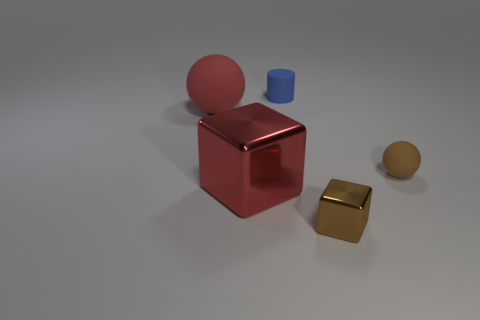There is a metal object that is the same color as the tiny matte ball; what shape is it?
Keep it short and to the point. Cube. How many rubber cylinders have the same size as the blue rubber object?
Your response must be concise. 0. What material is the big red object that is the same shape as the brown metallic thing?
Your answer should be very brief. Metal. What color is the rubber sphere that is left of the brown ball?
Your answer should be very brief. Red. Are there more small brown rubber balls to the left of the large metal cube than brown blocks?
Give a very brief answer. No. What is the color of the small sphere?
Ensure brevity in your answer.  Brown. The small matte thing on the right side of the metallic object that is to the right of the red thing on the right side of the big sphere is what shape?
Keep it short and to the point. Sphere. What is the object that is behind the small brown matte thing and right of the large sphere made of?
Keep it short and to the point. Rubber. There is a red object that is in front of the small rubber object that is in front of the matte cylinder; what shape is it?
Provide a succinct answer. Cube. Is there anything else that is the same color as the small metal cube?
Your response must be concise. Yes. 